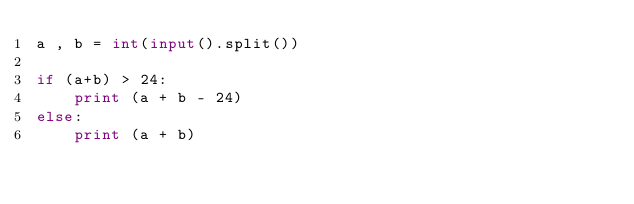Convert code to text. <code><loc_0><loc_0><loc_500><loc_500><_Python_>a , b = int(input().split())

if (a+b) > 24:
	print (a + b - 24)
else:
  	print (a + b)</code> 